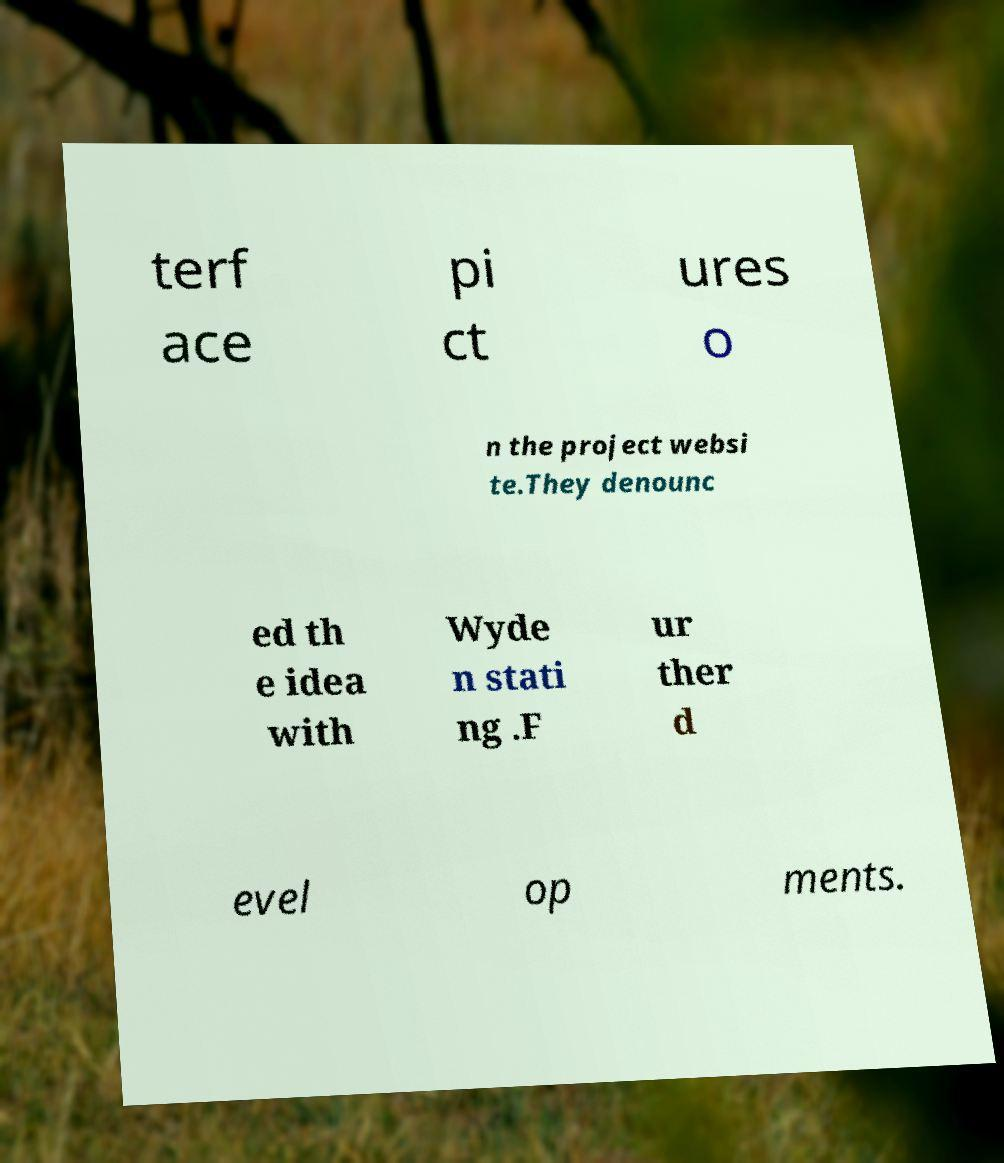There's text embedded in this image that I need extracted. Can you transcribe it verbatim? terf ace pi ct ures o n the project websi te.They denounc ed th e idea with Wyde n stati ng .F ur ther d evel op ments. 